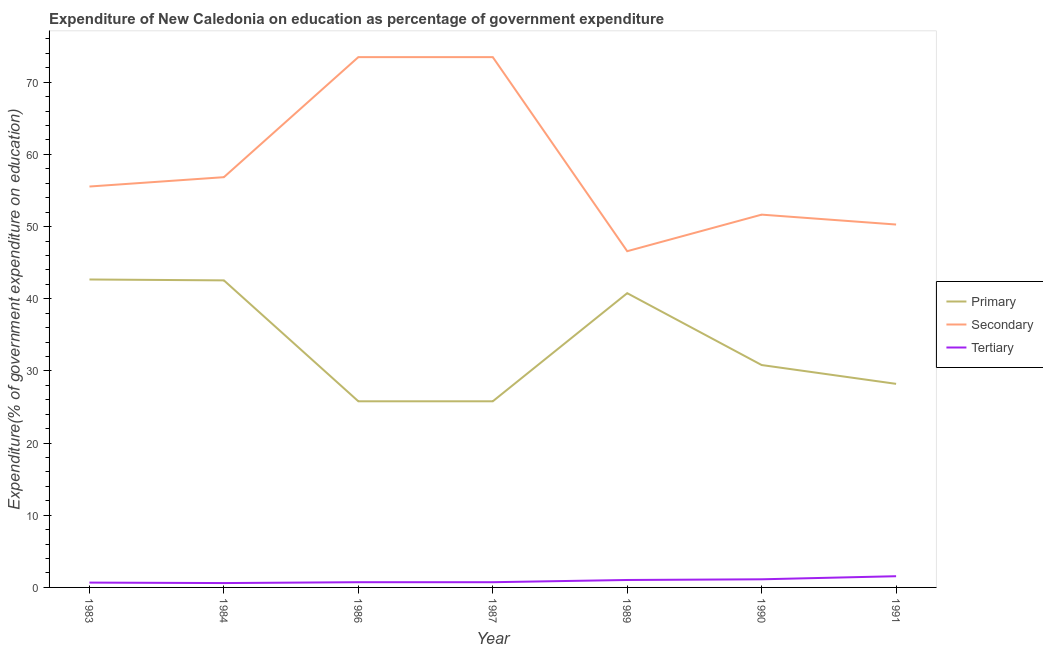How many different coloured lines are there?
Ensure brevity in your answer.  3. Is the number of lines equal to the number of legend labels?
Provide a succinct answer. Yes. What is the expenditure on primary education in 1986?
Make the answer very short. 25.79. Across all years, what is the maximum expenditure on primary education?
Provide a short and direct response. 42.67. Across all years, what is the minimum expenditure on primary education?
Offer a very short reply. 25.79. In which year was the expenditure on tertiary education minimum?
Offer a very short reply. 1984. What is the total expenditure on secondary education in the graph?
Provide a short and direct response. 407.9. What is the difference between the expenditure on secondary education in 1989 and that in 1991?
Offer a terse response. -3.69. What is the difference between the expenditure on primary education in 1989 and the expenditure on secondary education in 1991?
Offer a terse response. -9.51. What is the average expenditure on secondary education per year?
Give a very brief answer. 58.27. In the year 1989, what is the difference between the expenditure on tertiary education and expenditure on secondary education?
Make the answer very short. -45.56. In how many years, is the expenditure on secondary education greater than 70 %?
Your response must be concise. 2. What is the ratio of the expenditure on primary education in 1990 to that in 1991?
Make the answer very short. 1.09. Is the expenditure on primary education in 1987 less than that in 1989?
Offer a terse response. Yes. Is the difference between the expenditure on secondary education in 1983 and 1991 greater than the difference between the expenditure on primary education in 1983 and 1991?
Your response must be concise. No. What is the difference between the highest and the second highest expenditure on secondary education?
Your answer should be very brief. 6.999999999379725e-5. What is the difference between the highest and the lowest expenditure on primary education?
Your answer should be very brief. 16.88. Is the sum of the expenditure on tertiary education in 1983 and 1991 greater than the maximum expenditure on secondary education across all years?
Make the answer very short. No. Is it the case that in every year, the sum of the expenditure on primary education and expenditure on secondary education is greater than the expenditure on tertiary education?
Ensure brevity in your answer.  Yes. Does the expenditure on tertiary education monotonically increase over the years?
Your answer should be very brief. No. Is the expenditure on primary education strictly greater than the expenditure on secondary education over the years?
Provide a succinct answer. No. Is the expenditure on secondary education strictly less than the expenditure on primary education over the years?
Offer a very short reply. No. How many years are there in the graph?
Your answer should be very brief. 7. What is the difference between two consecutive major ticks on the Y-axis?
Give a very brief answer. 10. Are the values on the major ticks of Y-axis written in scientific E-notation?
Provide a short and direct response. No. Does the graph contain any zero values?
Give a very brief answer. No. Where does the legend appear in the graph?
Your answer should be compact. Center right. What is the title of the graph?
Your answer should be very brief. Expenditure of New Caledonia on education as percentage of government expenditure. What is the label or title of the X-axis?
Offer a very short reply. Year. What is the label or title of the Y-axis?
Make the answer very short. Expenditure(% of government expenditure on education). What is the Expenditure(% of government expenditure on education) of Primary in 1983?
Provide a short and direct response. 42.67. What is the Expenditure(% of government expenditure on education) of Secondary in 1983?
Make the answer very short. 55.55. What is the Expenditure(% of government expenditure on education) of Tertiary in 1983?
Give a very brief answer. 0.67. What is the Expenditure(% of government expenditure on education) of Primary in 1984?
Your response must be concise. 42.55. What is the Expenditure(% of government expenditure on education) in Secondary in 1984?
Provide a succinct answer. 56.85. What is the Expenditure(% of government expenditure on education) in Tertiary in 1984?
Provide a succinct answer. 0.6. What is the Expenditure(% of government expenditure on education) in Primary in 1986?
Provide a succinct answer. 25.79. What is the Expenditure(% of government expenditure on education) in Secondary in 1986?
Keep it short and to the point. 73.48. What is the Expenditure(% of government expenditure on education) of Tertiary in 1986?
Your response must be concise. 0.72. What is the Expenditure(% of government expenditure on education) in Primary in 1987?
Provide a short and direct response. 25.79. What is the Expenditure(% of government expenditure on education) in Secondary in 1987?
Your answer should be compact. 73.48. What is the Expenditure(% of government expenditure on education) in Tertiary in 1987?
Make the answer very short. 0.72. What is the Expenditure(% of government expenditure on education) of Primary in 1989?
Offer a very short reply. 40.77. What is the Expenditure(% of government expenditure on education) of Secondary in 1989?
Your answer should be very brief. 46.59. What is the Expenditure(% of government expenditure on education) in Tertiary in 1989?
Ensure brevity in your answer.  1.03. What is the Expenditure(% of government expenditure on education) in Primary in 1990?
Make the answer very short. 30.82. What is the Expenditure(% of government expenditure on education) in Secondary in 1990?
Your answer should be very brief. 51.66. What is the Expenditure(% of government expenditure on education) of Tertiary in 1990?
Offer a very short reply. 1.13. What is the Expenditure(% of government expenditure on education) in Primary in 1991?
Your answer should be very brief. 28.21. What is the Expenditure(% of government expenditure on education) in Secondary in 1991?
Ensure brevity in your answer.  50.29. What is the Expenditure(% of government expenditure on education) of Tertiary in 1991?
Give a very brief answer. 1.55. Across all years, what is the maximum Expenditure(% of government expenditure on education) of Primary?
Provide a succinct answer. 42.67. Across all years, what is the maximum Expenditure(% of government expenditure on education) in Secondary?
Provide a short and direct response. 73.48. Across all years, what is the maximum Expenditure(% of government expenditure on education) of Tertiary?
Offer a very short reply. 1.55. Across all years, what is the minimum Expenditure(% of government expenditure on education) of Primary?
Keep it short and to the point. 25.79. Across all years, what is the minimum Expenditure(% of government expenditure on education) in Secondary?
Make the answer very short. 46.59. Across all years, what is the minimum Expenditure(% of government expenditure on education) in Tertiary?
Give a very brief answer. 0.6. What is the total Expenditure(% of government expenditure on education) of Primary in the graph?
Your answer should be very brief. 236.6. What is the total Expenditure(% of government expenditure on education) of Secondary in the graph?
Offer a terse response. 407.9. What is the total Expenditure(% of government expenditure on education) in Tertiary in the graph?
Provide a short and direct response. 6.43. What is the difference between the Expenditure(% of government expenditure on education) in Primary in 1983 and that in 1984?
Your answer should be very brief. 0.12. What is the difference between the Expenditure(% of government expenditure on education) of Secondary in 1983 and that in 1984?
Your answer should be compact. -1.3. What is the difference between the Expenditure(% of government expenditure on education) of Tertiary in 1983 and that in 1984?
Keep it short and to the point. 0.07. What is the difference between the Expenditure(% of government expenditure on education) in Primary in 1983 and that in 1986?
Make the answer very short. 16.88. What is the difference between the Expenditure(% of government expenditure on education) in Secondary in 1983 and that in 1986?
Offer a very short reply. -17.93. What is the difference between the Expenditure(% of government expenditure on education) in Tertiary in 1983 and that in 1986?
Your answer should be very brief. -0.05. What is the difference between the Expenditure(% of government expenditure on education) of Primary in 1983 and that in 1987?
Ensure brevity in your answer.  16.88. What is the difference between the Expenditure(% of government expenditure on education) of Secondary in 1983 and that in 1987?
Keep it short and to the point. -17.93. What is the difference between the Expenditure(% of government expenditure on education) in Tertiary in 1983 and that in 1987?
Provide a succinct answer. -0.05. What is the difference between the Expenditure(% of government expenditure on education) of Primary in 1983 and that in 1989?
Your answer should be very brief. 1.9. What is the difference between the Expenditure(% of government expenditure on education) of Secondary in 1983 and that in 1989?
Offer a very short reply. 8.96. What is the difference between the Expenditure(% of government expenditure on education) in Tertiary in 1983 and that in 1989?
Provide a short and direct response. -0.36. What is the difference between the Expenditure(% of government expenditure on education) of Primary in 1983 and that in 1990?
Offer a terse response. 11.86. What is the difference between the Expenditure(% of government expenditure on education) in Secondary in 1983 and that in 1990?
Keep it short and to the point. 3.9. What is the difference between the Expenditure(% of government expenditure on education) in Tertiary in 1983 and that in 1990?
Your response must be concise. -0.46. What is the difference between the Expenditure(% of government expenditure on education) of Primary in 1983 and that in 1991?
Offer a very short reply. 14.46. What is the difference between the Expenditure(% of government expenditure on education) in Secondary in 1983 and that in 1991?
Provide a short and direct response. 5.27. What is the difference between the Expenditure(% of government expenditure on education) of Tertiary in 1983 and that in 1991?
Make the answer very short. -0.88. What is the difference between the Expenditure(% of government expenditure on education) of Primary in 1984 and that in 1986?
Offer a very short reply. 16.76. What is the difference between the Expenditure(% of government expenditure on education) in Secondary in 1984 and that in 1986?
Give a very brief answer. -16.63. What is the difference between the Expenditure(% of government expenditure on education) of Tertiary in 1984 and that in 1986?
Your response must be concise. -0.12. What is the difference between the Expenditure(% of government expenditure on education) in Primary in 1984 and that in 1987?
Make the answer very short. 16.76. What is the difference between the Expenditure(% of government expenditure on education) in Secondary in 1984 and that in 1987?
Make the answer very short. -16.63. What is the difference between the Expenditure(% of government expenditure on education) of Tertiary in 1984 and that in 1987?
Provide a succinct answer. -0.12. What is the difference between the Expenditure(% of government expenditure on education) of Primary in 1984 and that in 1989?
Your response must be concise. 1.77. What is the difference between the Expenditure(% of government expenditure on education) of Secondary in 1984 and that in 1989?
Offer a terse response. 10.26. What is the difference between the Expenditure(% of government expenditure on education) in Tertiary in 1984 and that in 1989?
Give a very brief answer. -0.43. What is the difference between the Expenditure(% of government expenditure on education) in Primary in 1984 and that in 1990?
Offer a terse response. 11.73. What is the difference between the Expenditure(% of government expenditure on education) of Secondary in 1984 and that in 1990?
Give a very brief answer. 5.19. What is the difference between the Expenditure(% of government expenditure on education) in Tertiary in 1984 and that in 1990?
Your answer should be very brief. -0.52. What is the difference between the Expenditure(% of government expenditure on education) of Primary in 1984 and that in 1991?
Keep it short and to the point. 14.34. What is the difference between the Expenditure(% of government expenditure on education) of Secondary in 1984 and that in 1991?
Ensure brevity in your answer.  6.56. What is the difference between the Expenditure(% of government expenditure on education) of Tertiary in 1984 and that in 1991?
Make the answer very short. -0.95. What is the difference between the Expenditure(% of government expenditure on education) in Secondary in 1986 and that in 1987?
Your answer should be very brief. -0. What is the difference between the Expenditure(% of government expenditure on education) in Primary in 1986 and that in 1989?
Provide a succinct answer. -14.98. What is the difference between the Expenditure(% of government expenditure on education) of Secondary in 1986 and that in 1989?
Your answer should be very brief. 26.89. What is the difference between the Expenditure(% of government expenditure on education) in Tertiary in 1986 and that in 1989?
Ensure brevity in your answer.  -0.31. What is the difference between the Expenditure(% of government expenditure on education) of Primary in 1986 and that in 1990?
Make the answer very short. -5.02. What is the difference between the Expenditure(% of government expenditure on education) of Secondary in 1986 and that in 1990?
Offer a very short reply. 21.83. What is the difference between the Expenditure(% of government expenditure on education) of Tertiary in 1986 and that in 1990?
Keep it short and to the point. -0.4. What is the difference between the Expenditure(% of government expenditure on education) in Primary in 1986 and that in 1991?
Make the answer very short. -2.42. What is the difference between the Expenditure(% of government expenditure on education) in Secondary in 1986 and that in 1991?
Keep it short and to the point. 23.2. What is the difference between the Expenditure(% of government expenditure on education) of Tertiary in 1986 and that in 1991?
Ensure brevity in your answer.  -0.83. What is the difference between the Expenditure(% of government expenditure on education) of Primary in 1987 and that in 1989?
Your answer should be very brief. -14.98. What is the difference between the Expenditure(% of government expenditure on education) of Secondary in 1987 and that in 1989?
Your response must be concise. 26.89. What is the difference between the Expenditure(% of government expenditure on education) of Tertiary in 1987 and that in 1989?
Ensure brevity in your answer.  -0.31. What is the difference between the Expenditure(% of government expenditure on education) in Primary in 1987 and that in 1990?
Your answer should be very brief. -5.02. What is the difference between the Expenditure(% of government expenditure on education) in Secondary in 1987 and that in 1990?
Ensure brevity in your answer.  21.83. What is the difference between the Expenditure(% of government expenditure on education) of Tertiary in 1987 and that in 1990?
Your answer should be compact. -0.4. What is the difference between the Expenditure(% of government expenditure on education) of Primary in 1987 and that in 1991?
Your answer should be compact. -2.42. What is the difference between the Expenditure(% of government expenditure on education) of Secondary in 1987 and that in 1991?
Your response must be concise. 23.2. What is the difference between the Expenditure(% of government expenditure on education) in Tertiary in 1987 and that in 1991?
Give a very brief answer. -0.83. What is the difference between the Expenditure(% of government expenditure on education) of Primary in 1989 and that in 1990?
Provide a succinct answer. 9.96. What is the difference between the Expenditure(% of government expenditure on education) in Secondary in 1989 and that in 1990?
Provide a short and direct response. -5.07. What is the difference between the Expenditure(% of government expenditure on education) in Tertiary in 1989 and that in 1990?
Keep it short and to the point. -0.09. What is the difference between the Expenditure(% of government expenditure on education) in Primary in 1989 and that in 1991?
Keep it short and to the point. 12.56. What is the difference between the Expenditure(% of government expenditure on education) in Secondary in 1989 and that in 1991?
Your answer should be compact. -3.69. What is the difference between the Expenditure(% of government expenditure on education) in Tertiary in 1989 and that in 1991?
Keep it short and to the point. -0.52. What is the difference between the Expenditure(% of government expenditure on education) of Primary in 1990 and that in 1991?
Make the answer very short. 2.61. What is the difference between the Expenditure(% of government expenditure on education) in Secondary in 1990 and that in 1991?
Your response must be concise. 1.37. What is the difference between the Expenditure(% of government expenditure on education) in Tertiary in 1990 and that in 1991?
Your answer should be compact. -0.43. What is the difference between the Expenditure(% of government expenditure on education) of Primary in 1983 and the Expenditure(% of government expenditure on education) of Secondary in 1984?
Provide a succinct answer. -14.18. What is the difference between the Expenditure(% of government expenditure on education) of Primary in 1983 and the Expenditure(% of government expenditure on education) of Tertiary in 1984?
Provide a succinct answer. 42.07. What is the difference between the Expenditure(% of government expenditure on education) of Secondary in 1983 and the Expenditure(% of government expenditure on education) of Tertiary in 1984?
Make the answer very short. 54.95. What is the difference between the Expenditure(% of government expenditure on education) in Primary in 1983 and the Expenditure(% of government expenditure on education) in Secondary in 1986?
Keep it short and to the point. -30.81. What is the difference between the Expenditure(% of government expenditure on education) in Primary in 1983 and the Expenditure(% of government expenditure on education) in Tertiary in 1986?
Keep it short and to the point. 41.95. What is the difference between the Expenditure(% of government expenditure on education) in Secondary in 1983 and the Expenditure(% of government expenditure on education) in Tertiary in 1986?
Provide a succinct answer. 54.83. What is the difference between the Expenditure(% of government expenditure on education) of Primary in 1983 and the Expenditure(% of government expenditure on education) of Secondary in 1987?
Keep it short and to the point. -30.81. What is the difference between the Expenditure(% of government expenditure on education) in Primary in 1983 and the Expenditure(% of government expenditure on education) in Tertiary in 1987?
Make the answer very short. 41.95. What is the difference between the Expenditure(% of government expenditure on education) of Secondary in 1983 and the Expenditure(% of government expenditure on education) of Tertiary in 1987?
Make the answer very short. 54.83. What is the difference between the Expenditure(% of government expenditure on education) of Primary in 1983 and the Expenditure(% of government expenditure on education) of Secondary in 1989?
Provide a short and direct response. -3.92. What is the difference between the Expenditure(% of government expenditure on education) of Primary in 1983 and the Expenditure(% of government expenditure on education) of Tertiary in 1989?
Ensure brevity in your answer.  41.64. What is the difference between the Expenditure(% of government expenditure on education) of Secondary in 1983 and the Expenditure(% of government expenditure on education) of Tertiary in 1989?
Provide a short and direct response. 54.52. What is the difference between the Expenditure(% of government expenditure on education) of Primary in 1983 and the Expenditure(% of government expenditure on education) of Secondary in 1990?
Provide a short and direct response. -8.99. What is the difference between the Expenditure(% of government expenditure on education) in Primary in 1983 and the Expenditure(% of government expenditure on education) in Tertiary in 1990?
Ensure brevity in your answer.  41.55. What is the difference between the Expenditure(% of government expenditure on education) in Secondary in 1983 and the Expenditure(% of government expenditure on education) in Tertiary in 1990?
Make the answer very short. 54.43. What is the difference between the Expenditure(% of government expenditure on education) in Primary in 1983 and the Expenditure(% of government expenditure on education) in Secondary in 1991?
Your response must be concise. -7.62. What is the difference between the Expenditure(% of government expenditure on education) of Primary in 1983 and the Expenditure(% of government expenditure on education) of Tertiary in 1991?
Ensure brevity in your answer.  41.12. What is the difference between the Expenditure(% of government expenditure on education) in Secondary in 1983 and the Expenditure(% of government expenditure on education) in Tertiary in 1991?
Offer a very short reply. 54. What is the difference between the Expenditure(% of government expenditure on education) of Primary in 1984 and the Expenditure(% of government expenditure on education) of Secondary in 1986?
Offer a very short reply. -30.94. What is the difference between the Expenditure(% of government expenditure on education) of Primary in 1984 and the Expenditure(% of government expenditure on education) of Tertiary in 1986?
Keep it short and to the point. 41.82. What is the difference between the Expenditure(% of government expenditure on education) in Secondary in 1984 and the Expenditure(% of government expenditure on education) in Tertiary in 1986?
Provide a succinct answer. 56.12. What is the difference between the Expenditure(% of government expenditure on education) of Primary in 1984 and the Expenditure(% of government expenditure on education) of Secondary in 1987?
Provide a short and direct response. -30.94. What is the difference between the Expenditure(% of government expenditure on education) of Primary in 1984 and the Expenditure(% of government expenditure on education) of Tertiary in 1987?
Keep it short and to the point. 41.82. What is the difference between the Expenditure(% of government expenditure on education) of Secondary in 1984 and the Expenditure(% of government expenditure on education) of Tertiary in 1987?
Provide a short and direct response. 56.12. What is the difference between the Expenditure(% of government expenditure on education) of Primary in 1984 and the Expenditure(% of government expenditure on education) of Secondary in 1989?
Offer a terse response. -4.04. What is the difference between the Expenditure(% of government expenditure on education) of Primary in 1984 and the Expenditure(% of government expenditure on education) of Tertiary in 1989?
Keep it short and to the point. 41.52. What is the difference between the Expenditure(% of government expenditure on education) in Secondary in 1984 and the Expenditure(% of government expenditure on education) in Tertiary in 1989?
Keep it short and to the point. 55.82. What is the difference between the Expenditure(% of government expenditure on education) of Primary in 1984 and the Expenditure(% of government expenditure on education) of Secondary in 1990?
Your response must be concise. -9.11. What is the difference between the Expenditure(% of government expenditure on education) in Primary in 1984 and the Expenditure(% of government expenditure on education) in Tertiary in 1990?
Make the answer very short. 41.42. What is the difference between the Expenditure(% of government expenditure on education) of Secondary in 1984 and the Expenditure(% of government expenditure on education) of Tertiary in 1990?
Offer a very short reply. 55.72. What is the difference between the Expenditure(% of government expenditure on education) of Primary in 1984 and the Expenditure(% of government expenditure on education) of Secondary in 1991?
Your answer should be very brief. -7.74. What is the difference between the Expenditure(% of government expenditure on education) in Primary in 1984 and the Expenditure(% of government expenditure on education) in Tertiary in 1991?
Provide a short and direct response. 40.99. What is the difference between the Expenditure(% of government expenditure on education) of Secondary in 1984 and the Expenditure(% of government expenditure on education) of Tertiary in 1991?
Your answer should be compact. 55.3. What is the difference between the Expenditure(% of government expenditure on education) of Primary in 1986 and the Expenditure(% of government expenditure on education) of Secondary in 1987?
Your response must be concise. -47.69. What is the difference between the Expenditure(% of government expenditure on education) in Primary in 1986 and the Expenditure(% of government expenditure on education) in Tertiary in 1987?
Ensure brevity in your answer.  25.07. What is the difference between the Expenditure(% of government expenditure on education) of Secondary in 1986 and the Expenditure(% of government expenditure on education) of Tertiary in 1987?
Your response must be concise. 72.76. What is the difference between the Expenditure(% of government expenditure on education) in Primary in 1986 and the Expenditure(% of government expenditure on education) in Secondary in 1989?
Keep it short and to the point. -20.8. What is the difference between the Expenditure(% of government expenditure on education) in Primary in 1986 and the Expenditure(% of government expenditure on education) in Tertiary in 1989?
Your response must be concise. 24.76. What is the difference between the Expenditure(% of government expenditure on education) in Secondary in 1986 and the Expenditure(% of government expenditure on education) in Tertiary in 1989?
Your answer should be very brief. 72.45. What is the difference between the Expenditure(% of government expenditure on education) of Primary in 1986 and the Expenditure(% of government expenditure on education) of Secondary in 1990?
Your answer should be compact. -25.87. What is the difference between the Expenditure(% of government expenditure on education) of Primary in 1986 and the Expenditure(% of government expenditure on education) of Tertiary in 1990?
Keep it short and to the point. 24.67. What is the difference between the Expenditure(% of government expenditure on education) in Secondary in 1986 and the Expenditure(% of government expenditure on education) in Tertiary in 1990?
Offer a terse response. 72.36. What is the difference between the Expenditure(% of government expenditure on education) of Primary in 1986 and the Expenditure(% of government expenditure on education) of Secondary in 1991?
Offer a terse response. -24.49. What is the difference between the Expenditure(% of government expenditure on education) in Primary in 1986 and the Expenditure(% of government expenditure on education) in Tertiary in 1991?
Ensure brevity in your answer.  24.24. What is the difference between the Expenditure(% of government expenditure on education) in Secondary in 1986 and the Expenditure(% of government expenditure on education) in Tertiary in 1991?
Offer a terse response. 71.93. What is the difference between the Expenditure(% of government expenditure on education) of Primary in 1987 and the Expenditure(% of government expenditure on education) of Secondary in 1989?
Your response must be concise. -20.8. What is the difference between the Expenditure(% of government expenditure on education) in Primary in 1987 and the Expenditure(% of government expenditure on education) in Tertiary in 1989?
Provide a short and direct response. 24.76. What is the difference between the Expenditure(% of government expenditure on education) of Secondary in 1987 and the Expenditure(% of government expenditure on education) of Tertiary in 1989?
Your answer should be compact. 72.45. What is the difference between the Expenditure(% of government expenditure on education) in Primary in 1987 and the Expenditure(% of government expenditure on education) in Secondary in 1990?
Provide a succinct answer. -25.87. What is the difference between the Expenditure(% of government expenditure on education) in Primary in 1987 and the Expenditure(% of government expenditure on education) in Tertiary in 1990?
Ensure brevity in your answer.  24.67. What is the difference between the Expenditure(% of government expenditure on education) in Secondary in 1987 and the Expenditure(% of government expenditure on education) in Tertiary in 1990?
Offer a terse response. 72.36. What is the difference between the Expenditure(% of government expenditure on education) in Primary in 1987 and the Expenditure(% of government expenditure on education) in Secondary in 1991?
Give a very brief answer. -24.49. What is the difference between the Expenditure(% of government expenditure on education) in Primary in 1987 and the Expenditure(% of government expenditure on education) in Tertiary in 1991?
Ensure brevity in your answer.  24.24. What is the difference between the Expenditure(% of government expenditure on education) of Secondary in 1987 and the Expenditure(% of government expenditure on education) of Tertiary in 1991?
Your answer should be very brief. 71.93. What is the difference between the Expenditure(% of government expenditure on education) in Primary in 1989 and the Expenditure(% of government expenditure on education) in Secondary in 1990?
Make the answer very short. -10.88. What is the difference between the Expenditure(% of government expenditure on education) of Primary in 1989 and the Expenditure(% of government expenditure on education) of Tertiary in 1990?
Ensure brevity in your answer.  39.65. What is the difference between the Expenditure(% of government expenditure on education) in Secondary in 1989 and the Expenditure(% of government expenditure on education) in Tertiary in 1990?
Make the answer very short. 45.47. What is the difference between the Expenditure(% of government expenditure on education) in Primary in 1989 and the Expenditure(% of government expenditure on education) in Secondary in 1991?
Offer a very short reply. -9.51. What is the difference between the Expenditure(% of government expenditure on education) of Primary in 1989 and the Expenditure(% of government expenditure on education) of Tertiary in 1991?
Offer a very short reply. 39.22. What is the difference between the Expenditure(% of government expenditure on education) of Secondary in 1989 and the Expenditure(% of government expenditure on education) of Tertiary in 1991?
Offer a terse response. 45.04. What is the difference between the Expenditure(% of government expenditure on education) in Primary in 1990 and the Expenditure(% of government expenditure on education) in Secondary in 1991?
Give a very brief answer. -19.47. What is the difference between the Expenditure(% of government expenditure on education) of Primary in 1990 and the Expenditure(% of government expenditure on education) of Tertiary in 1991?
Provide a succinct answer. 29.26. What is the difference between the Expenditure(% of government expenditure on education) in Secondary in 1990 and the Expenditure(% of government expenditure on education) in Tertiary in 1991?
Ensure brevity in your answer.  50.1. What is the average Expenditure(% of government expenditure on education) in Primary per year?
Ensure brevity in your answer.  33.8. What is the average Expenditure(% of government expenditure on education) in Secondary per year?
Provide a succinct answer. 58.27. What is the average Expenditure(% of government expenditure on education) of Tertiary per year?
Offer a very short reply. 0.92. In the year 1983, what is the difference between the Expenditure(% of government expenditure on education) in Primary and Expenditure(% of government expenditure on education) in Secondary?
Provide a succinct answer. -12.88. In the year 1983, what is the difference between the Expenditure(% of government expenditure on education) in Primary and Expenditure(% of government expenditure on education) in Tertiary?
Your response must be concise. 42. In the year 1983, what is the difference between the Expenditure(% of government expenditure on education) of Secondary and Expenditure(% of government expenditure on education) of Tertiary?
Give a very brief answer. 54.88. In the year 1984, what is the difference between the Expenditure(% of government expenditure on education) in Primary and Expenditure(% of government expenditure on education) in Secondary?
Your answer should be compact. -14.3. In the year 1984, what is the difference between the Expenditure(% of government expenditure on education) of Primary and Expenditure(% of government expenditure on education) of Tertiary?
Your answer should be very brief. 41.94. In the year 1984, what is the difference between the Expenditure(% of government expenditure on education) in Secondary and Expenditure(% of government expenditure on education) in Tertiary?
Provide a succinct answer. 56.24. In the year 1986, what is the difference between the Expenditure(% of government expenditure on education) in Primary and Expenditure(% of government expenditure on education) in Secondary?
Provide a short and direct response. -47.69. In the year 1986, what is the difference between the Expenditure(% of government expenditure on education) in Primary and Expenditure(% of government expenditure on education) in Tertiary?
Ensure brevity in your answer.  25.07. In the year 1986, what is the difference between the Expenditure(% of government expenditure on education) in Secondary and Expenditure(% of government expenditure on education) in Tertiary?
Your answer should be very brief. 72.76. In the year 1987, what is the difference between the Expenditure(% of government expenditure on education) of Primary and Expenditure(% of government expenditure on education) of Secondary?
Keep it short and to the point. -47.69. In the year 1987, what is the difference between the Expenditure(% of government expenditure on education) in Primary and Expenditure(% of government expenditure on education) in Tertiary?
Offer a very short reply. 25.07. In the year 1987, what is the difference between the Expenditure(% of government expenditure on education) in Secondary and Expenditure(% of government expenditure on education) in Tertiary?
Your answer should be compact. 72.76. In the year 1989, what is the difference between the Expenditure(% of government expenditure on education) in Primary and Expenditure(% of government expenditure on education) in Secondary?
Make the answer very short. -5.82. In the year 1989, what is the difference between the Expenditure(% of government expenditure on education) in Primary and Expenditure(% of government expenditure on education) in Tertiary?
Keep it short and to the point. 39.74. In the year 1989, what is the difference between the Expenditure(% of government expenditure on education) of Secondary and Expenditure(% of government expenditure on education) of Tertiary?
Ensure brevity in your answer.  45.56. In the year 1990, what is the difference between the Expenditure(% of government expenditure on education) of Primary and Expenditure(% of government expenditure on education) of Secondary?
Provide a short and direct response. -20.84. In the year 1990, what is the difference between the Expenditure(% of government expenditure on education) in Primary and Expenditure(% of government expenditure on education) in Tertiary?
Your answer should be compact. 29.69. In the year 1990, what is the difference between the Expenditure(% of government expenditure on education) of Secondary and Expenditure(% of government expenditure on education) of Tertiary?
Keep it short and to the point. 50.53. In the year 1991, what is the difference between the Expenditure(% of government expenditure on education) of Primary and Expenditure(% of government expenditure on education) of Secondary?
Provide a succinct answer. -22.08. In the year 1991, what is the difference between the Expenditure(% of government expenditure on education) in Primary and Expenditure(% of government expenditure on education) in Tertiary?
Keep it short and to the point. 26.66. In the year 1991, what is the difference between the Expenditure(% of government expenditure on education) of Secondary and Expenditure(% of government expenditure on education) of Tertiary?
Your answer should be compact. 48.73. What is the ratio of the Expenditure(% of government expenditure on education) of Secondary in 1983 to that in 1984?
Make the answer very short. 0.98. What is the ratio of the Expenditure(% of government expenditure on education) of Tertiary in 1983 to that in 1984?
Your response must be concise. 1.11. What is the ratio of the Expenditure(% of government expenditure on education) in Primary in 1983 to that in 1986?
Ensure brevity in your answer.  1.65. What is the ratio of the Expenditure(% of government expenditure on education) in Secondary in 1983 to that in 1986?
Your answer should be very brief. 0.76. What is the ratio of the Expenditure(% of government expenditure on education) in Tertiary in 1983 to that in 1986?
Give a very brief answer. 0.92. What is the ratio of the Expenditure(% of government expenditure on education) of Primary in 1983 to that in 1987?
Offer a very short reply. 1.65. What is the ratio of the Expenditure(% of government expenditure on education) of Secondary in 1983 to that in 1987?
Give a very brief answer. 0.76. What is the ratio of the Expenditure(% of government expenditure on education) in Tertiary in 1983 to that in 1987?
Offer a terse response. 0.92. What is the ratio of the Expenditure(% of government expenditure on education) of Primary in 1983 to that in 1989?
Make the answer very short. 1.05. What is the ratio of the Expenditure(% of government expenditure on education) of Secondary in 1983 to that in 1989?
Your response must be concise. 1.19. What is the ratio of the Expenditure(% of government expenditure on education) in Tertiary in 1983 to that in 1989?
Give a very brief answer. 0.65. What is the ratio of the Expenditure(% of government expenditure on education) in Primary in 1983 to that in 1990?
Make the answer very short. 1.38. What is the ratio of the Expenditure(% of government expenditure on education) in Secondary in 1983 to that in 1990?
Your answer should be very brief. 1.08. What is the ratio of the Expenditure(% of government expenditure on education) of Tertiary in 1983 to that in 1990?
Provide a succinct answer. 0.59. What is the ratio of the Expenditure(% of government expenditure on education) of Primary in 1983 to that in 1991?
Give a very brief answer. 1.51. What is the ratio of the Expenditure(% of government expenditure on education) in Secondary in 1983 to that in 1991?
Offer a terse response. 1.1. What is the ratio of the Expenditure(% of government expenditure on education) in Tertiary in 1983 to that in 1991?
Ensure brevity in your answer.  0.43. What is the ratio of the Expenditure(% of government expenditure on education) of Primary in 1984 to that in 1986?
Provide a short and direct response. 1.65. What is the ratio of the Expenditure(% of government expenditure on education) of Secondary in 1984 to that in 1986?
Your response must be concise. 0.77. What is the ratio of the Expenditure(% of government expenditure on education) in Tertiary in 1984 to that in 1986?
Provide a short and direct response. 0.83. What is the ratio of the Expenditure(% of government expenditure on education) in Primary in 1984 to that in 1987?
Keep it short and to the point. 1.65. What is the ratio of the Expenditure(% of government expenditure on education) of Secondary in 1984 to that in 1987?
Provide a short and direct response. 0.77. What is the ratio of the Expenditure(% of government expenditure on education) in Tertiary in 1984 to that in 1987?
Provide a succinct answer. 0.83. What is the ratio of the Expenditure(% of government expenditure on education) in Primary in 1984 to that in 1989?
Make the answer very short. 1.04. What is the ratio of the Expenditure(% of government expenditure on education) in Secondary in 1984 to that in 1989?
Provide a succinct answer. 1.22. What is the ratio of the Expenditure(% of government expenditure on education) of Tertiary in 1984 to that in 1989?
Your answer should be very brief. 0.59. What is the ratio of the Expenditure(% of government expenditure on education) in Primary in 1984 to that in 1990?
Provide a short and direct response. 1.38. What is the ratio of the Expenditure(% of government expenditure on education) of Secondary in 1984 to that in 1990?
Offer a very short reply. 1.1. What is the ratio of the Expenditure(% of government expenditure on education) in Tertiary in 1984 to that in 1990?
Keep it short and to the point. 0.54. What is the ratio of the Expenditure(% of government expenditure on education) in Primary in 1984 to that in 1991?
Your answer should be compact. 1.51. What is the ratio of the Expenditure(% of government expenditure on education) in Secondary in 1984 to that in 1991?
Offer a terse response. 1.13. What is the ratio of the Expenditure(% of government expenditure on education) of Tertiary in 1984 to that in 1991?
Provide a short and direct response. 0.39. What is the ratio of the Expenditure(% of government expenditure on education) in Primary in 1986 to that in 1987?
Your answer should be compact. 1. What is the ratio of the Expenditure(% of government expenditure on education) in Primary in 1986 to that in 1989?
Provide a succinct answer. 0.63. What is the ratio of the Expenditure(% of government expenditure on education) in Secondary in 1986 to that in 1989?
Provide a succinct answer. 1.58. What is the ratio of the Expenditure(% of government expenditure on education) in Tertiary in 1986 to that in 1989?
Ensure brevity in your answer.  0.7. What is the ratio of the Expenditure(% of government expenditure on education) in Primary in 1986 to that in 1990?
Your response must be concise. 0.84. What is the ratio of the Expenditure(% of government expenditure on education) of Secondary in 1986 to that in 1990?
Ensure brevity in your answer.  1.42. What is the ratio of the Expenditure(% of government expenditure on education) in Tertiary in 1986 to that in 1990?
Ensure brevity in your answer.  0.64. What is the ratio of the Expenditure(% of government expenditure on education) of Primary in 1986 to that in 1991?
Offer a terse response. 0.91. What is the ratio of the Expenditure(% of government expenditure on education) in Secondary in 1986 to that in 1991?
Keep it short and to the point. 1.46. What is the ratio of the Expenditure(% of government expenditure on education) of Tertiary in 1986 to that in 1991?
Keep it short and to the point. 0.47. What is the ratio of the Expenditure(% of government expenditure on education) of Primary in 1987 to that in 1989?
Your answer should be compact. 0.63. What is the ratio of the Expenditure(% of government expenditure on education) in Secondary in 1987 to that in 1989?
Your answer should be very brief. 1.58. What is the ratio of the Expenditure(% of government expenditure on education) in Tertiary in 1987 to that in 1989?
Ensure brevity in your answer.  0.7. What is the ratio of the Expenditure(% of government expenditure on education) of Primary in 1987 to that in 1990?
Offer a very short reply. 0.84. What is the ratio of the Expenditure(% of government expenditure on education) in Secondary in 1987 to that in 1990?
Keep it short and to the point. 1.42. What is the ratio of the Expenditure(% of government expenditure on education) in Tertiary in 1987 to that in 1990?
Offer a terse response. 0.64. What is the ratio of the Expenditure(% of government expenditure on education) of Primary in 1987 to that in 1991?
Ensure brevity in your answer.  0.91. What is the ratio of the Expenditure(% of government expenditure on education) in Secondary in 1987 to that in 1991?
Provide a succinct answer. 1.46. What is the ratio of the Expenditure(% of government expenditure on education) of Tertiary in 1987 to that in 1991?
Ensure brevity in your answer.  0.47. What is the ratio of the Expenditure(% of government expenditure on education) of Primary in 1989 to that in 1990?
Offer a very short reply. 1.32. What is the ratio of the Expenditure(% of government expenditure on education) in Secondary in 1989 to that in 1990?
Your response must be concise. 0.9. What is the ratio of the Expenditure(% of government expenditure on education) in Tertiary in 1989 to that in 1990?
Your answer should be very brief. 0.92. What is the ratio of the Expenditure(% of government expenditure on education) of Primary in 1989 to that in 1991?
Offer a terse response. 1.45. What is the ratio of the Expenditure(% of government expenditure on education) in Secondary in 1989 to that in 1991?
Give a very brief answer. 0.93. What is the ratio of the Expenditure(% of government expenditure on education) of Tertiary in 1989 to that in 1991?
Offer a very short reply. 0.66. What is the ratio of the Expenditure(% of government expenditure on education) of Primary in 1990 to that in 1991?
Your response must be concise. 1.09. What is the ratio of the Expenditure(% of government expenditure on education) of Secondary in 1990 to that in 1991?
Offer a terse response. 1.03. What is the ratio of the Expenditure(% of government expenditure on education) of Tertiary in 1990 to that in 1991?
Make the answer very short. 0.72. What is the difference between the highest and the second highest Expenditure(% of government expenditure on education) in Primary?
Your answer should be compact. 0.12. What is the difference between the highest and the second highest Expenditure(% of government expenditure on education) in Secondary?
Your answer should be compact. 0. What is the difference between the highest and the second highest Expenditure(% of government expenditure on education) of Tertiary?
Give a very brief answer. 0.43. What is the difference between the highest and the lowest Expenditure(% of government expenditure on education) of Primary?
Offer a very short reply. 16.88. What is the difference between the highest and the lowest Expenditure(% of government expenditure on education) of Secondary?
Your answer should be very brief. 26.89. What is the difference between the highest and the lowest Expenditure(% of government expenditure on education) in Tertiary?
Ensure brevity in your answer.  0.95. 